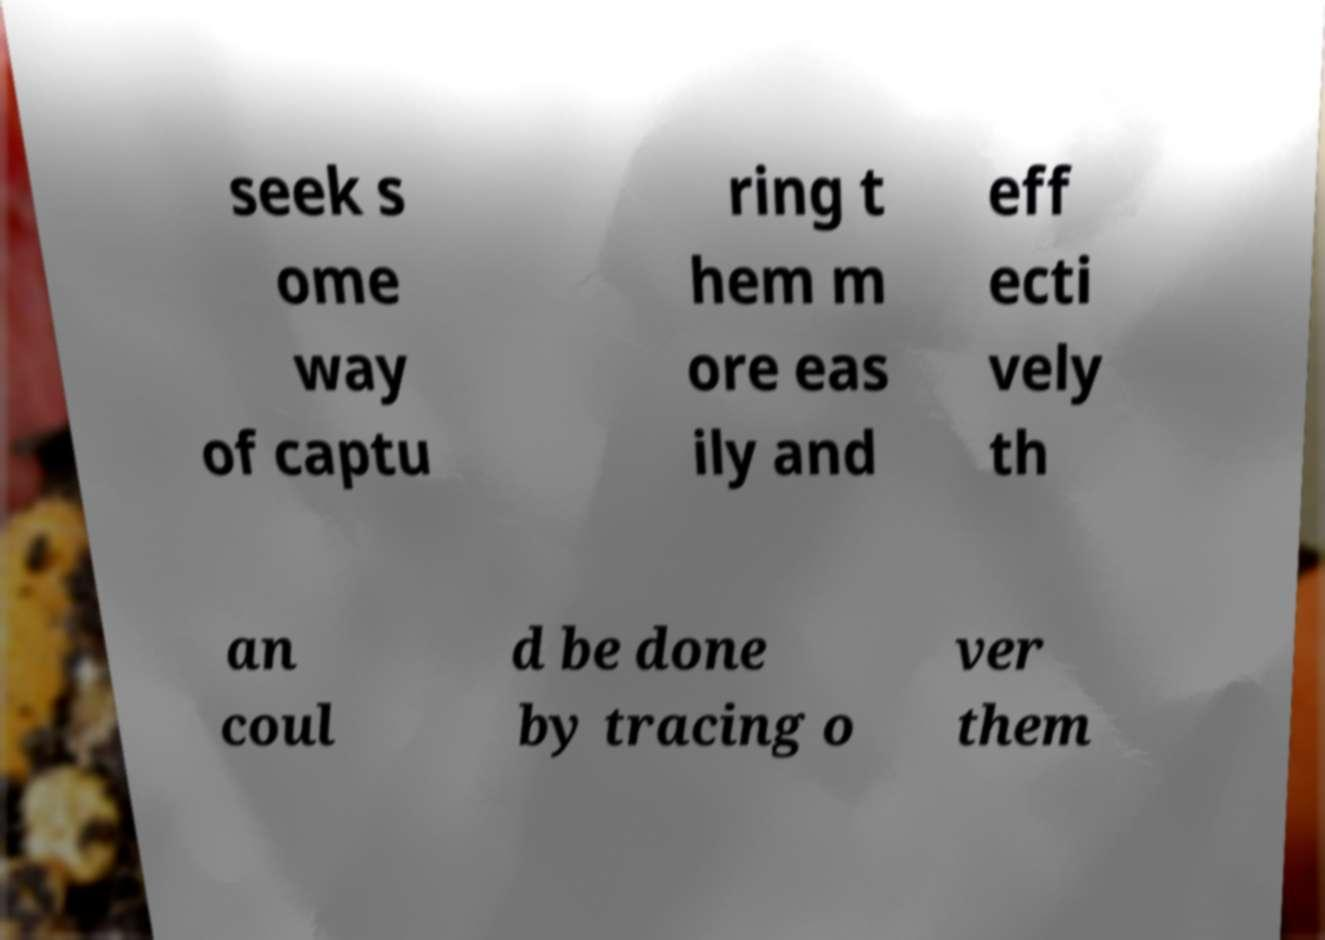Could you assist in decoding the text presented in this image and type it out clearly? seek s ome way of captu ring t hem m ore eas ily and eff ecti vely th an coul d be done by tracing o ver them 